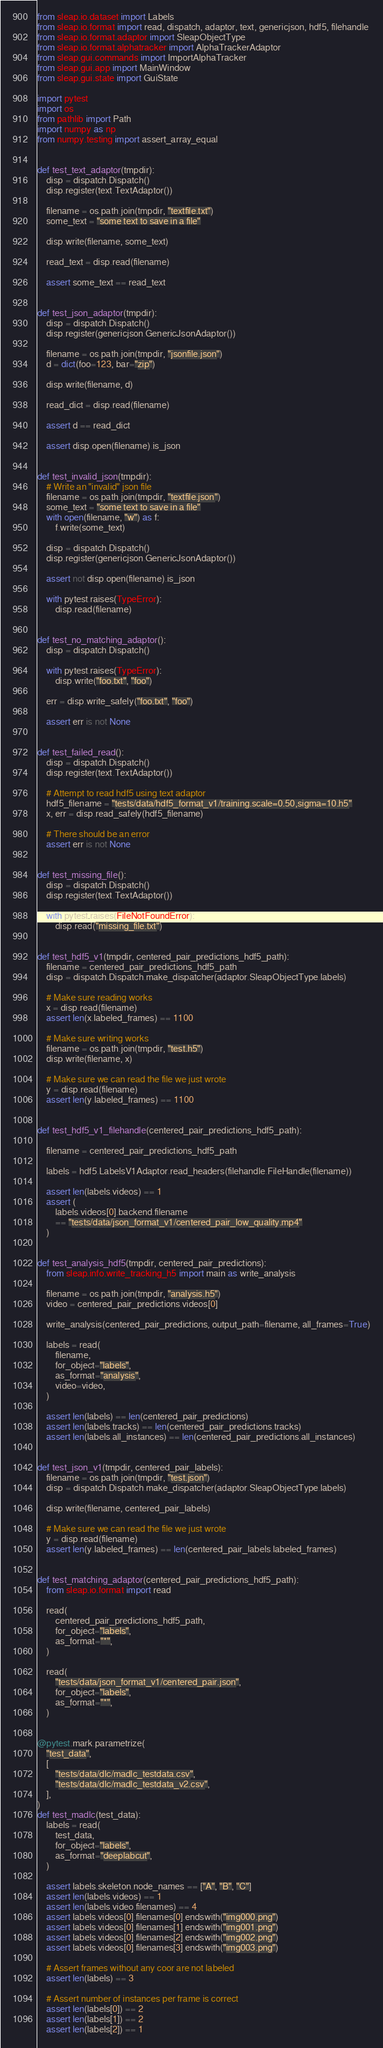Convert code to text. <code><loc_0><loc_0><loc_500><loc_500><_Python_>from sleap.io.dataset import Labels
from sleap.io.format import read, dispatch, adaptor, text, genericjson, hdf5, filehandle
from sleap.io.format.adaptor import SleapObjectType
from sleap.io.format.alphatracker import AlphaTrackerAdaptor
from sleap.gui.commands import ImportAlphaTracker
from sleap.gui.app import MainWindow
from sleap.gui.state import GuiState

import pytest
import os
from pathlib import Path
import numpy as np
from numpy.testing import assert_array_equal


def test_text_adaptor(tmpdir):
    disp = dispatch.Dispatch()
    disp.register(text.TextAdaptor())

    filename = os.path.join(tmpdir, "textfile.txt")
    some_text = "some text to save in a file"

    disp.write(filename, some_text)

    read_text = disp.read(filename)

    assert some_text == read_text


def test_json_adaptor(tmpdir):
    disp = dispatch.Dispatch()
    disp.register(genericjson.GenericJsonAdaptor())

    filename = os.path.join(tmpdir, "jsonfile.json")
    d = dict(foo=123, bar="zip")

    disp.write(filename, d)

    read_dict = disp.read(filename)

    assert d == read_dict

    assert disp.open(filename).is_json


def test_invalid_json(tmpdir):
    # Write an "invalid" json file
    filename = os.path.join(tmpdir, "textfile.json")
    some_text = "some text to save in a file"
    with open(filename, "w") as f:
        f.write(some_text)

    disp = dispatch.Dispatch()
    disp.register(genericjson.GenericJsonAdaptor())

    assert not disp.open(filename).is_json

    with pytest.raises(TypeError):
        disp.read(filename)


def test_no_matching_adaptor():
    disp = dispatch.Dispatch()

    with pytest.raises(TypeError):
        disp.write("foo.txt", "foo")

    err = disp.write_safely("foo.txt", "foo")

    assert err is not None


def test_failed_read():
    disp = dispatch.Dispatch()
    disp.register(text.TextAdaptor())

    # Attempt to read hdf5 using text adaptor
    hdf5_filename = "tests/data/hdf5_format_v1/training.scale=0.50,sigma=10.h5"
    x, err = disp.read_safely(hdf5_filename)

    # There should be an error
    assert err is not None


def test_missing_file():
    disp = dispatch.Dispatch()
    disp.register(text.TextAdaptor())

    with pytest.raises(FileNotFoundError):
        disp.read("missing_file.txt")


def test_hdf5_v1(tmpdir, centered_pair_predictions_hdf5_path):
    filename = centered_pair_predictions_hdf5_path
    disp = dispatch.Dispatch.make_dispatcher(adaptor.SleapObjectType.labels)

    # Make sure reading works
    x = disp.read(filename)
    assert len(x.labeled_frames) == 1100

    # Make sure writing works
    filename = os.path.join(tmpdir, "test.h5")
    disp.write(filename, x)

    # Make sure we can read the file we just wrote
    y = disp.read(filename)
    assert len(y.labeled_frames) == 1100


def test_hdf5_v1_filehandle(centered_pair_predictions_hdf5_path):

    filename = centered_pair_predictions_hdf5_path

    labels = hdf5.LabelsV1Adaptor.read_headers(filehandle.FileHandle(filename))

    assert len(labels.videos) == 1
    assert (
        labels.videos[0].backend.filename
        == "tests/data/json_format_v1/centered_pair_low_quality.mp4"
    )


def test_analysis_hdf5(tmpdir, centered_pair_predictions):
    from sleap.info.write_tracking_h5 import main as write_analysis

    filename = os.path.join(tmpdir, "analysis.h5")
    video = centered_pair_predictions.videos[0]

    write_analysis(centered_pair_predictions, output_path=filename, all_frames=True)

    labels = read(
        filename,
        for_object="labels",
        as_format="analysis",
        video=video,
    )

    assert len(labels) == len(centered_pair_predictions)
    assert len(labels.tracks) == len(centered_pair_predictions.tracks)
    assert len(labels.all_instances) == len(centered_pair_predictions.all_instances)


def test_json_v1(tmpdir, centered_pair_labels):
    filename = os.path.join(tmpdir, "test.json")
    disp = dispatch.Dispatch.make_dispatcher(adaptor.SleapObjectType.labels)

    disp.write(filename, centered_pair_labels)

    # Make sure we can read the file we just wrote
    y = disp.read(filename)
    assert len(y.labeled_frames) == len(centered_pair_labels.labeled_frames)


def test_matching_adaptor(centered_pair_predictions_hdf5_path):
    from sleap.io.format import read

    read(
        centered_pair_predictions_hdf5_path,
        for_object="labels",
        as_format="*",
    )

    read(
        "tests/data/json_format_v1/centered_pair.json",
        for_object="labels",
        as_format="*",
    )


@pytest.mark.parametrize(
    "test_data",
    [
        "tests/data/dlc/madlc_testdata.csv",
        "tests/data/dlc/madlc_testdata_v2.csv",
    ],
)
def test_madlc(test_data):
    labels = read(
        test_data,
        for_object="labels",
        as_format="deeplabcut",
    )

    assert labels.skeleton.node_names == ["A", "B", "C"]
    assert len(labels.videos) == 1
    assert len(labels.video.filenames) == 4
    assert labels.videos[0].filenames[0].endswith("img000.png")
    assert labels.videos[0].filenames[1].endswith("img001.png")
    assert labels.videos[0].filenames[2].endswith("img002.png")
    assert labels.videos[0].filenames[3].endswith("img003.png")

    # Assert frames without any coor are not labeled
    assert len(labels) == 3

    # Assert number of instances per frame is correct
    assert len(labels[0]) == 2
    assert len(labels[1]) == 2
    assert len(labels[2]) == 1
</code> 